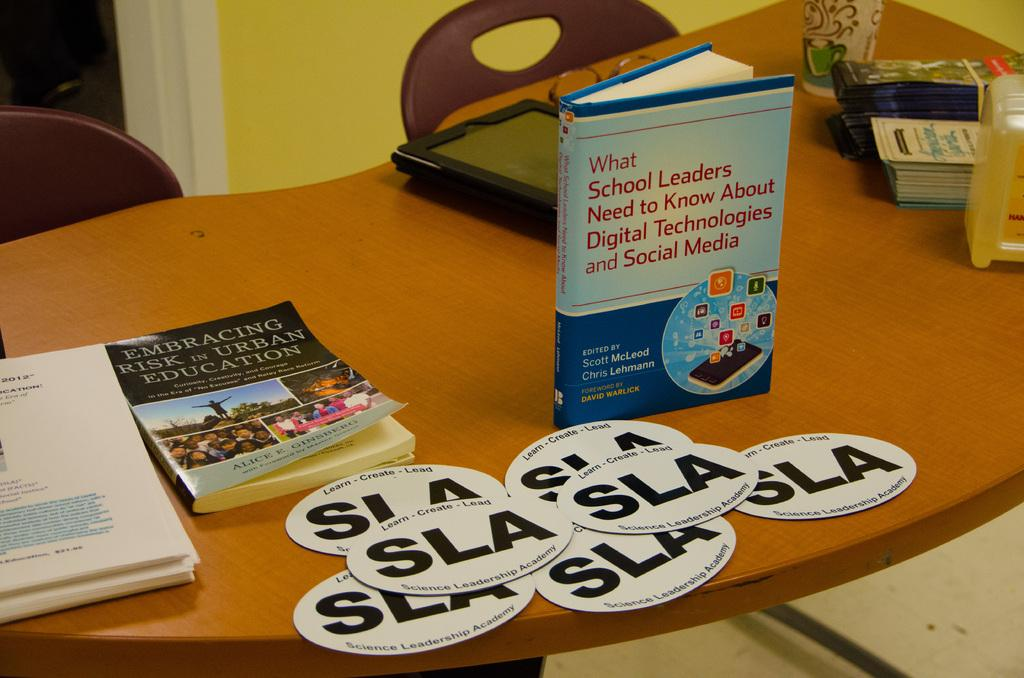<image>
Share a concise interpretation of the image provided. A standing book that discusses what school leaders need to know. 